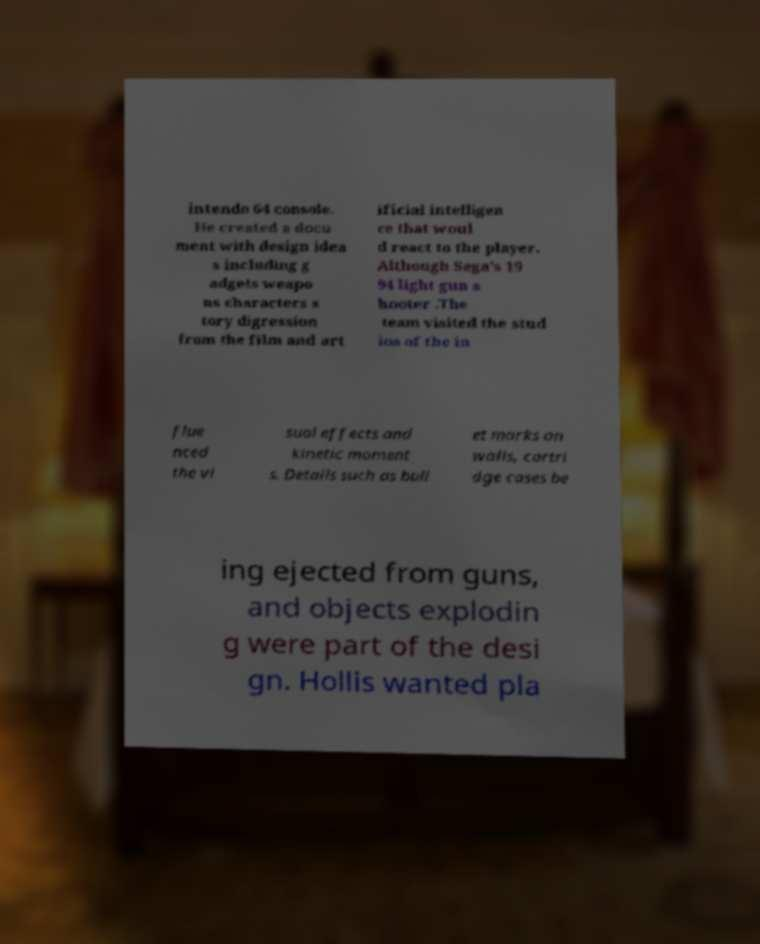Please read and relay the text visible in this image. What does it say? intendo 64 console. He created a docu ment with design idea s including g adgets weapo ns characters s tory digression from the film and art ificial intelligen ce that woul d react to the player. Although Sega's 19 94 light gun s hooter .The team visited the stud ios of the in flue nced the vi sual effects and kinetic moment s. Details such as bull et marks on walls, cartri dge cases be ing ejected from guns, and objects explodin g were part of the desi gn. Hollis wanted pla 